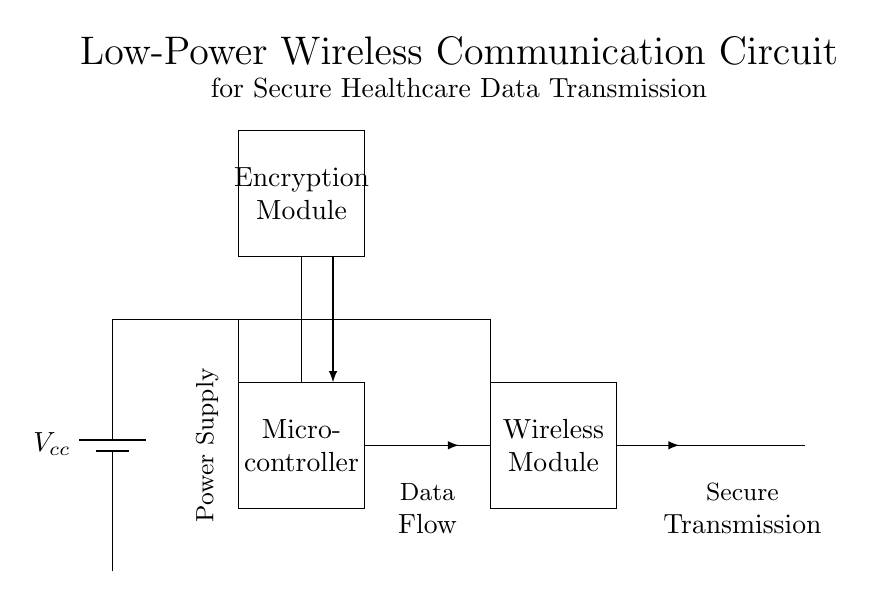What is the voltage supply in this circuit? The circuit diagram shows a power supply labeled as \(V_{cc}\), which typically indicates a voltage source providing power to the circuit components. Although the specific voltage value is not mentioned, the source generally provides a standard voltage level (commonly 5V or 3.3V in low-power applications).
Answer: Vcc What type of module is used for secure data transmission? The diagram includes a component labeled "Wireless Module," indicating it is responsible for the wireless transmission of data. The use of a wireless module allows for the communication of healthcare data without needing physical connections.
Answer: Wireless Module What component provides encryption for the data? The circuit features an "Encryption Module" designed to secure the data being transmitted. This module is critical for protecting sensitive healthcare information from unauthorized access during transmission between insurance companies and healthcare providers.
Answer: Encryption Module How many main components are present in the circuit? By analyzing the diagram, there are four main components: the power supply, microcontroller, wireless module, and encryption module. Count each distinct rectangle or labeled element representing a primary function within the circuit.
Answer: Four What is the function of the microcontroller in this circuit? The microcontroller acts as the central processing unit that controls the operations of the circuit, including data processing and interfacing between the wireless module and encryption module. Its task is crucial for managing data flow and executing programmed instructions.
Answer: Control operations What indicates the flow of data within this circuit? The arrows in the circuit diagram represent the direction of data flow. Specifically, arrows show how data moves from the microcontroller to the encryption module, then to the wireless module, indicating the entire process of data transmission and encryption is mapped clearly.
Answer: Arrows 